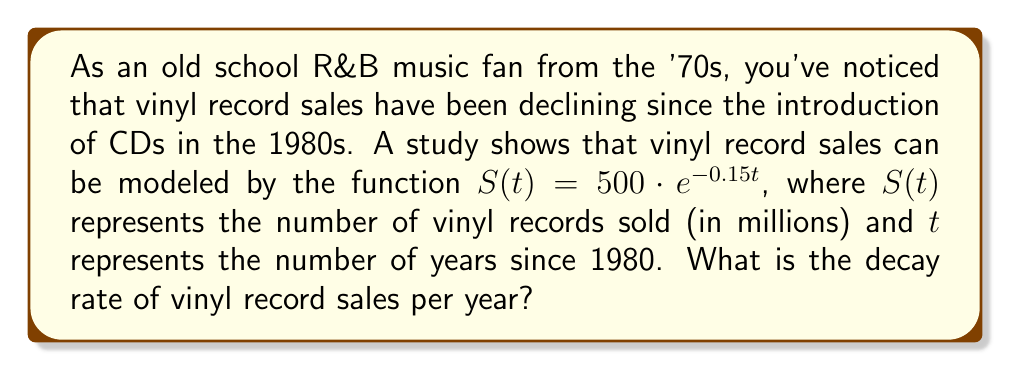Give your solution to this math problem. To find the decay rate of vinyl record sales, we need to analyze the given exponential function:

$$S(t) = 500 \cdot e^{-0.15t}$$

This function is in the general form of an exponential decay function:

$$f(t) = A \cdot e^{-rt}$$

Where:
- $A$ is the initial amount (500 million records in this case)
- $e$ is Euler's number (approximately 2.71828)
- $r$ is the decay rate
- $t$ is the time variable

In our function, we can see that the exponent is $-0.15t$. This means that the decay rate $r$ is 0.15.

To interpret this decay rate:
1. The decay rate of 0.15 means that the sales decrease by 15% per year.
2. We can verify this by calculating the percent change from one year to the next:
   $$\text{Percent change} = (e^{-0.15} - 1) \times 100\% \approx -13.93\%$$

3. This is approximately a 14% decrease per year, which is consistent with our 15% decay rate (the small difference is due to compounding).

Therefore, the decay rate of vinyl record sales is 0.15, or 15% per year.
Answer: The decay rate of vinyl record sales is 0.15 (or 15%) per year. 